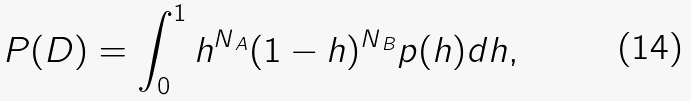Convert formula to latex. <formula><loc_0><loc_0><loc_500><loc_500>P ( D ) = \int _ { 0 } ^ { 1 } h ^ { N _ { \, A } } ( 1 - h ) ^ { N _ { \, B } } p ( h ) d h ,</formula> 